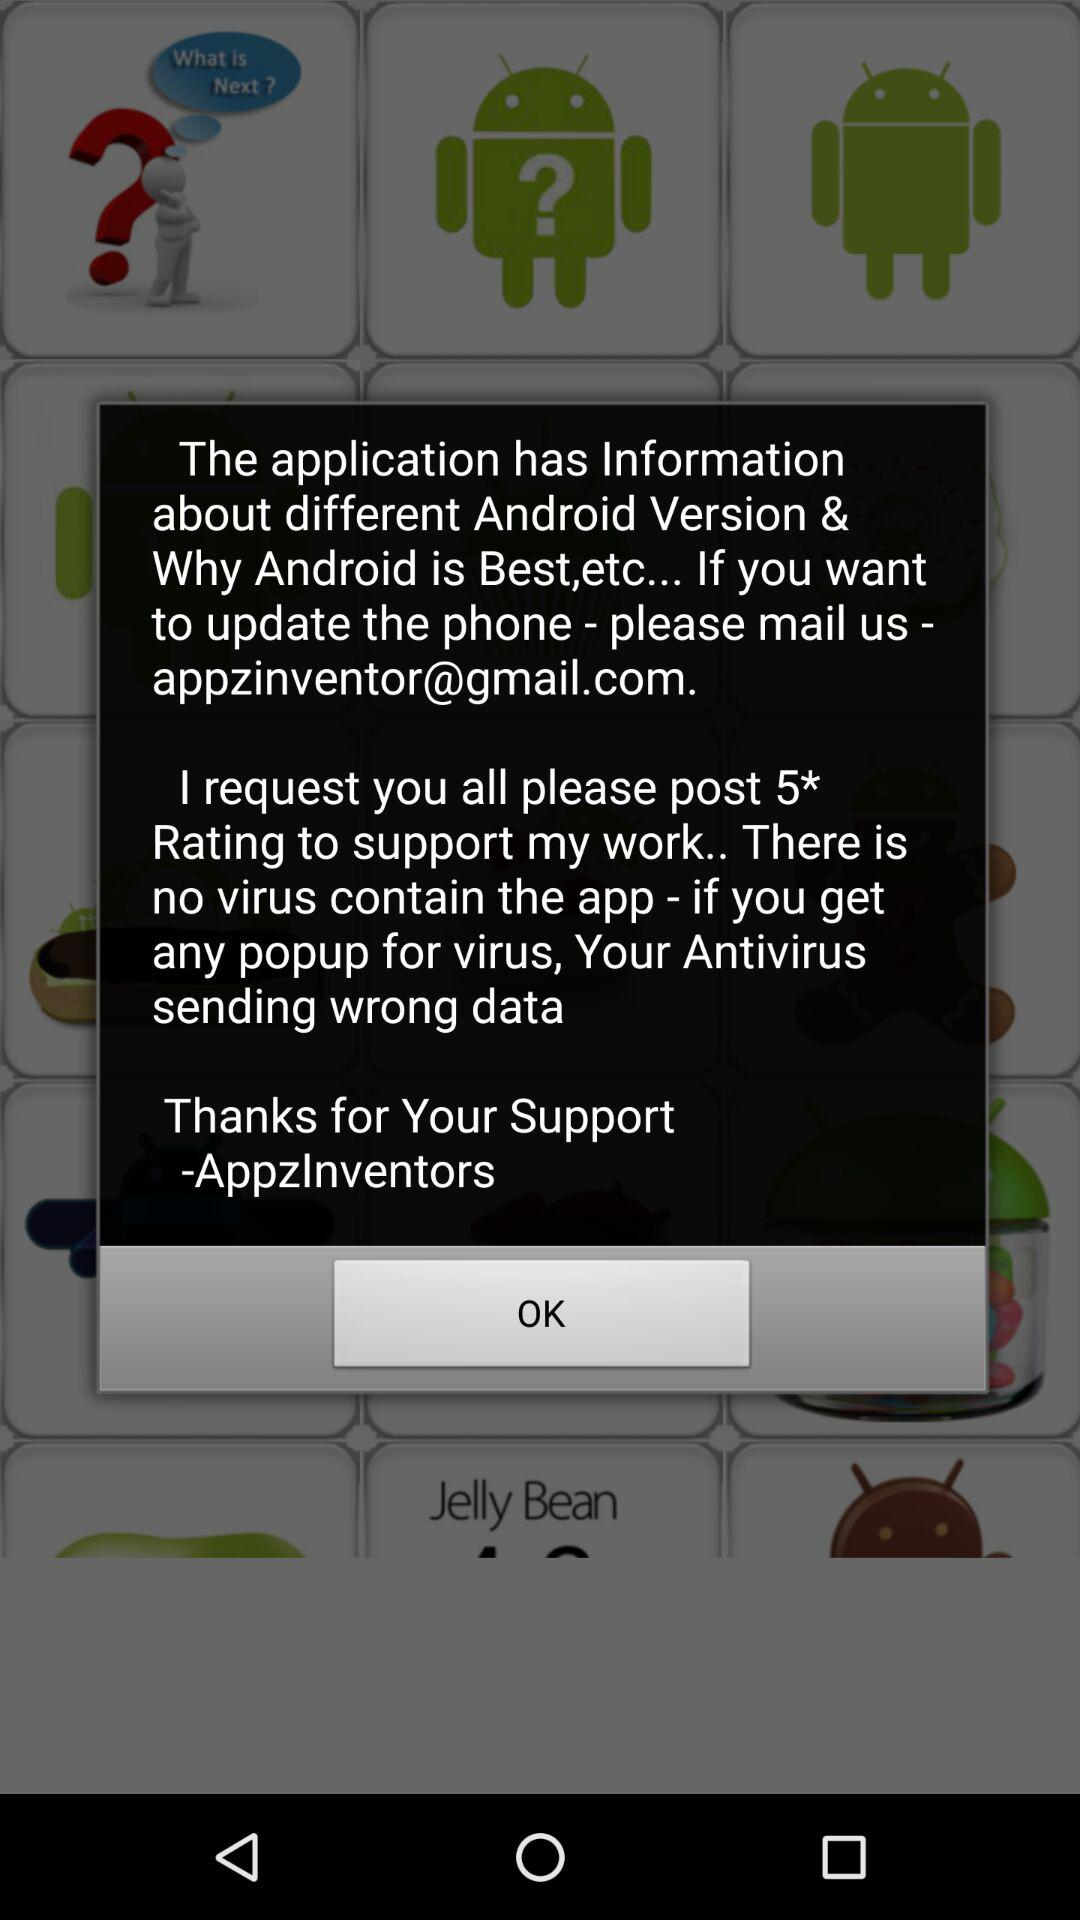How many stars did the developer request to support for the work? The developer is requesting for 5 star rating. 